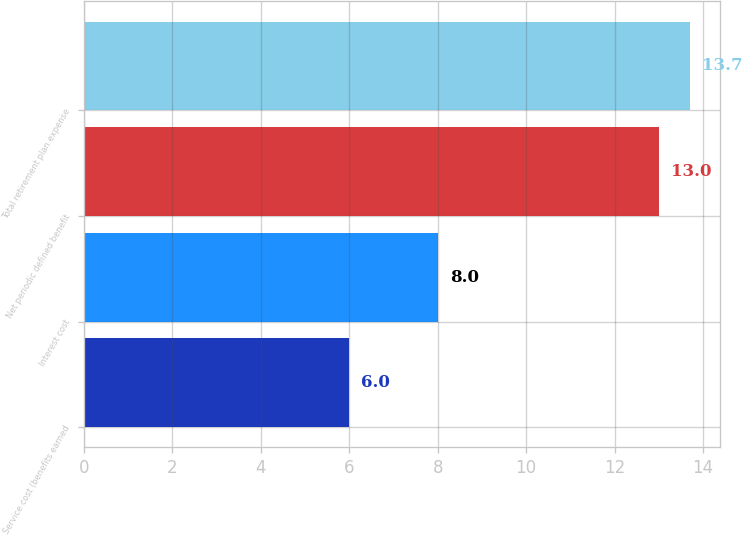Convert chart to OTSL. <chart><loc_0><loc_0><loc_500><loc_500><bar_chart><fcel>Service cost (benefits earned<fcel>Interest cost<fcel>Net periodic defined benefit<fcel>Total retirement plan expense<nl><fcel>6<fcel>8<fcel>13<fcel>13.7<nl></chart> 